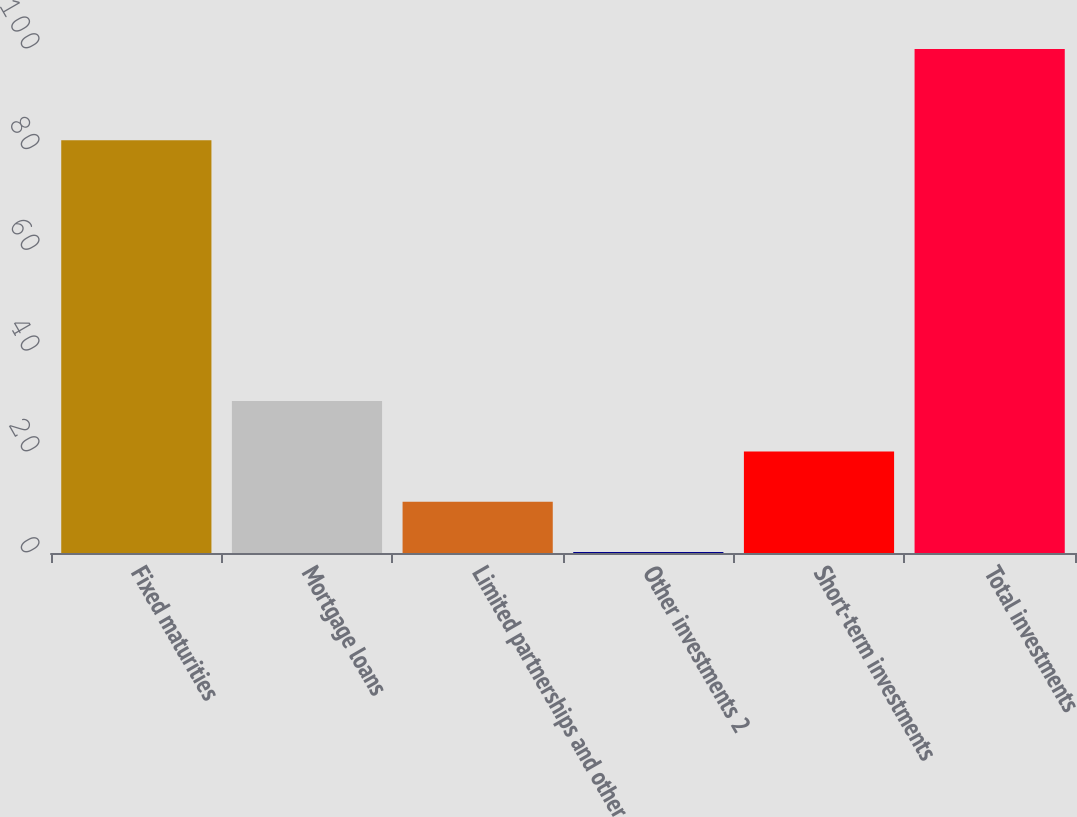Convert chart to OTSL. <chart><loc_0><loc_0><loc_500><loc_500><bar_chart><fcel>Fixed maturities<fcel>Mortgage loans<fcel>Limited partnerships and other<fcel>Other investments 2<fcel>Short-term investments<fcel>Total investments<nl><fcel>81.9<fcel>30.14<fcel>10.18<fcel>0.2<fcel>20.16<fcel>100<nl></chart> 